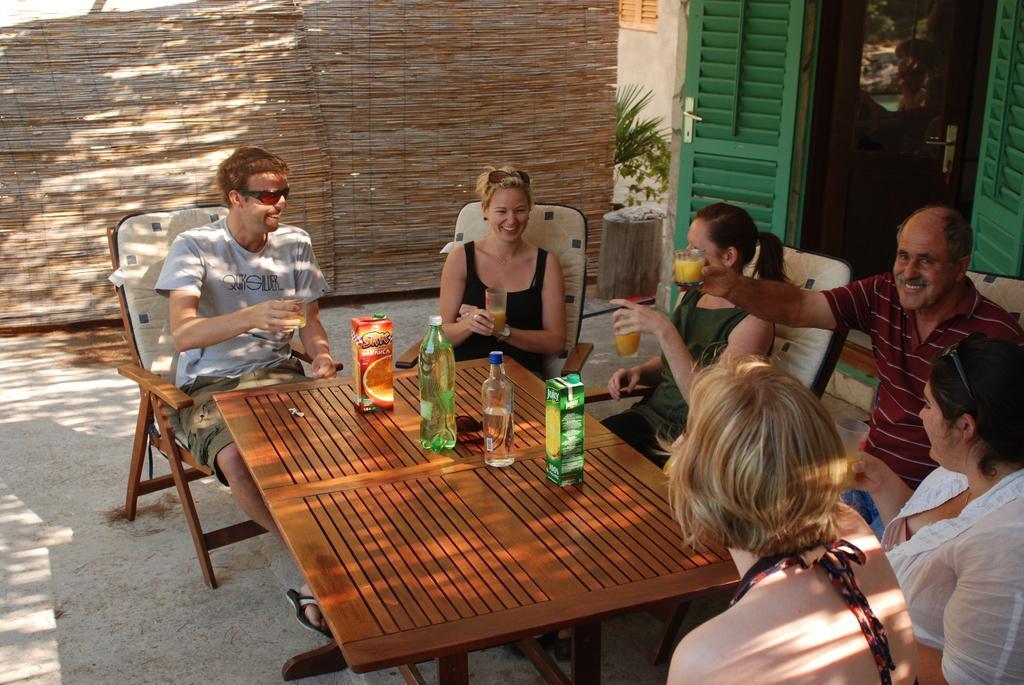How would you summarize this image in a sentence or two? In this image I can see group of people holding the glasses. There is a table in front of them. On the table there are bottles. 